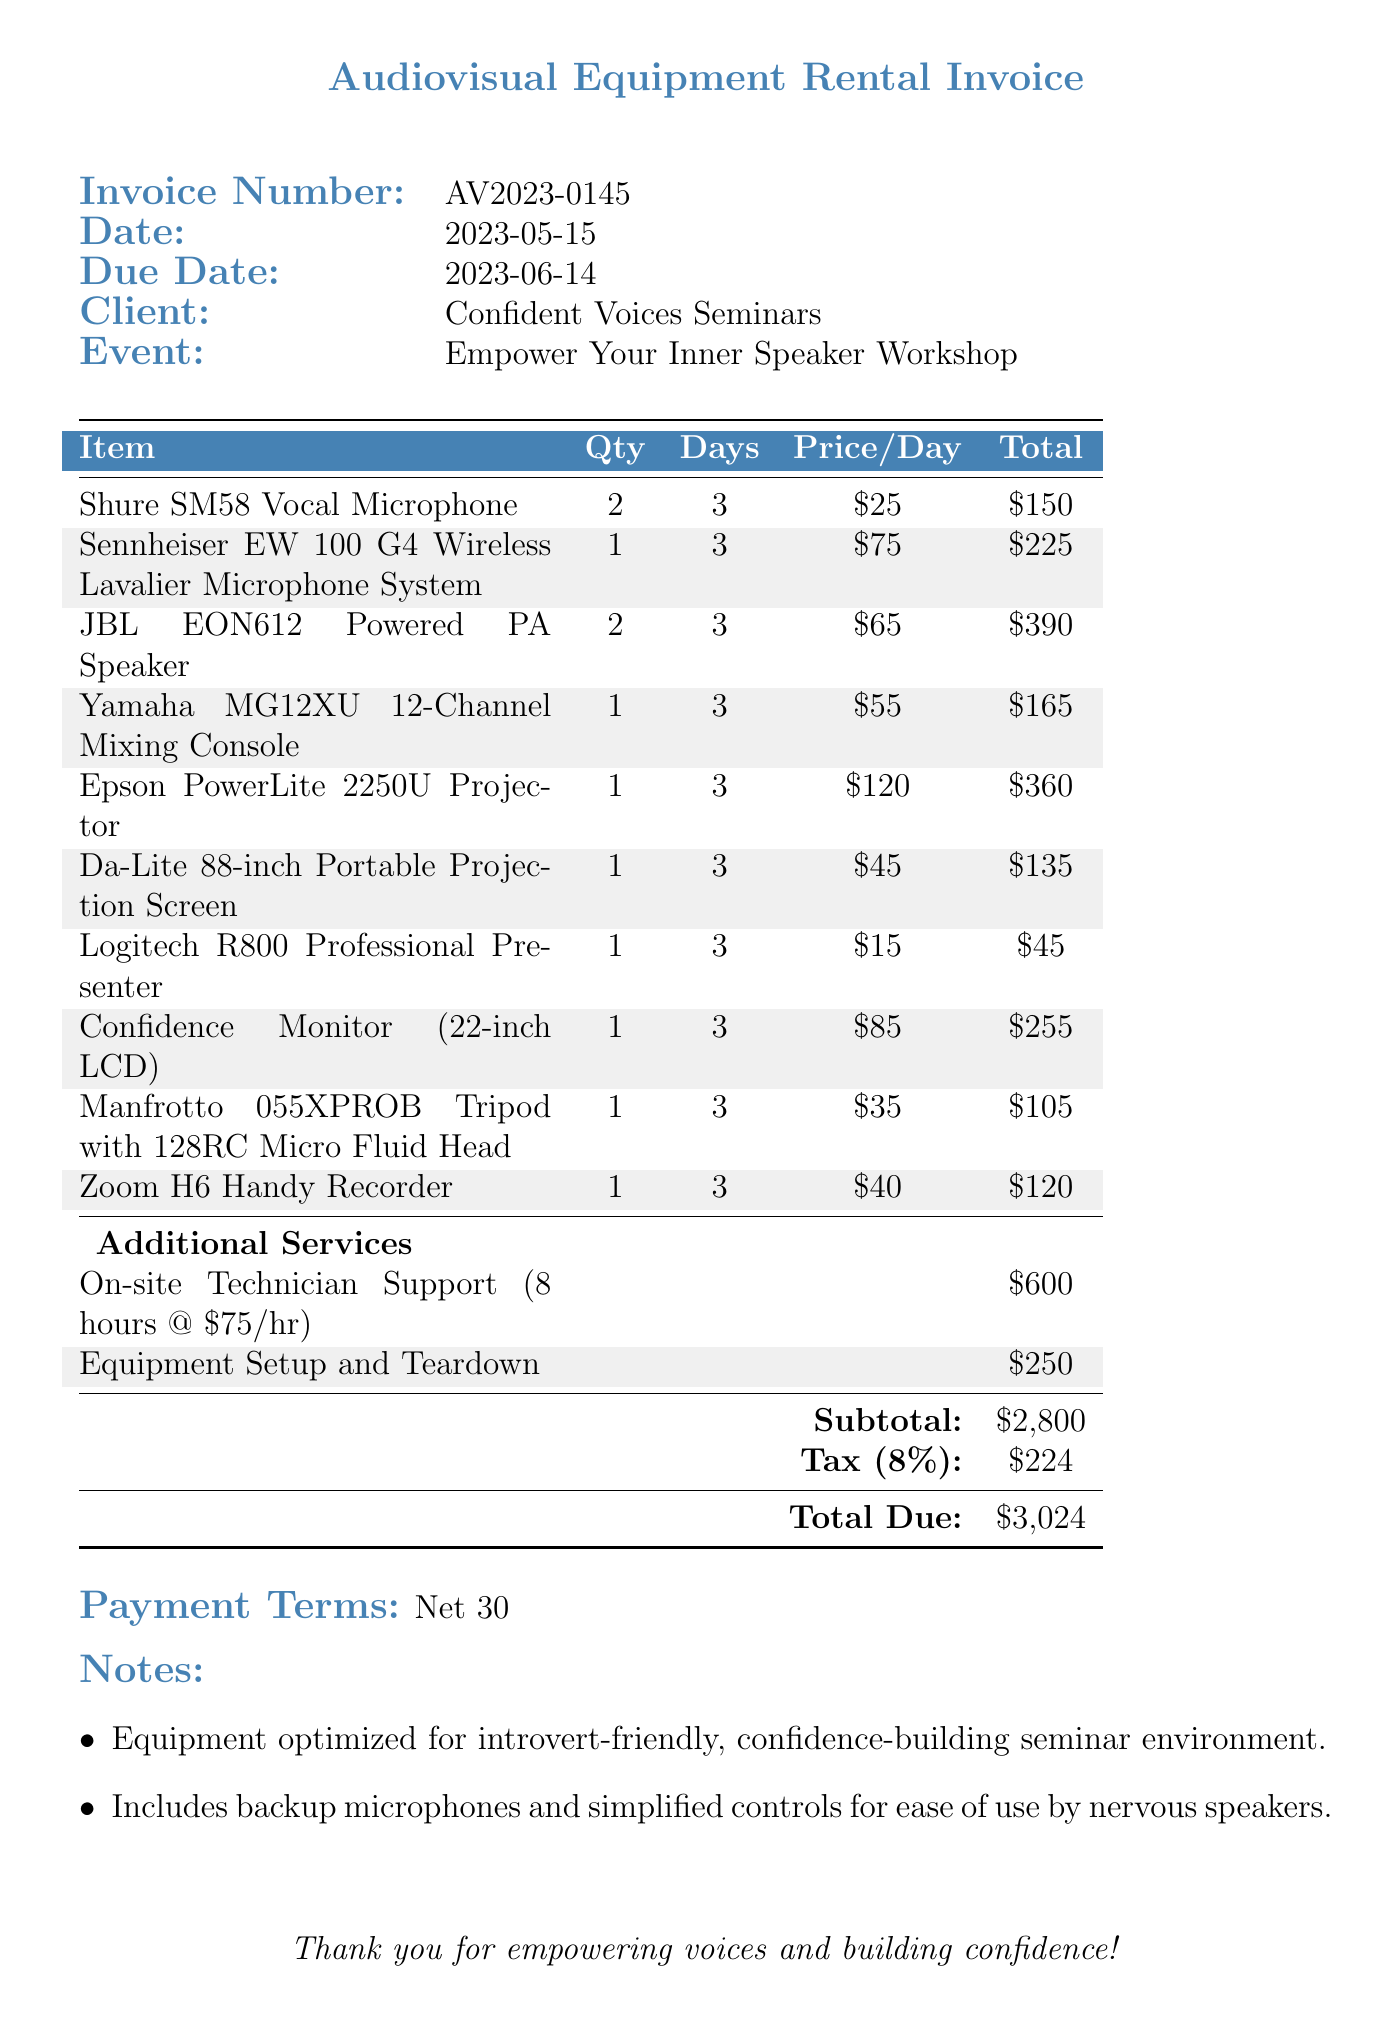What is the invoice number? The invoice number is a unique identifier for the document, which is typically found at the top of the invoice.
Answer: AV2023-0145 What is the due date? The due date indicates when the payment for the invoice is expected, specified in the document.
Answer: 2023-06-14 How many days were the items rented? The number of days rented is consistent across all items listed in the invoice, as provided in the itemized list.
Answer: 3 What is the subtotal amount? The subtotal is the total before tax and additional charges, referenced in the financial summary of the invoice.
Answer: $2,800 What item has the highest rental price per day? The highest rental price per day can be identified in the itemized list of rental items based on the specified prices.
Answer: Epson PowerLite 2250U Projector How many hours of technician support were billed? The number of hours billed for technician support is specified next to the service and is essential for calculating the total cost.
Answer: 8 What is the total due amount? The total due reflects the final amount payable after including taxes and additional services, found near the end of the invoice.
Answer: $3,024 What type of payment terms are specified? The payment terms outline the duration within which the payment should be made based on the invoice date, indicated explicitly in the document.
Answer: Net 30 What was the event name for which the equipment was rented? The event name refers to the specific seminar or workshop hosted, as detailed in the client information section.
Answer: Empower Your Inner Speaker Workshop 